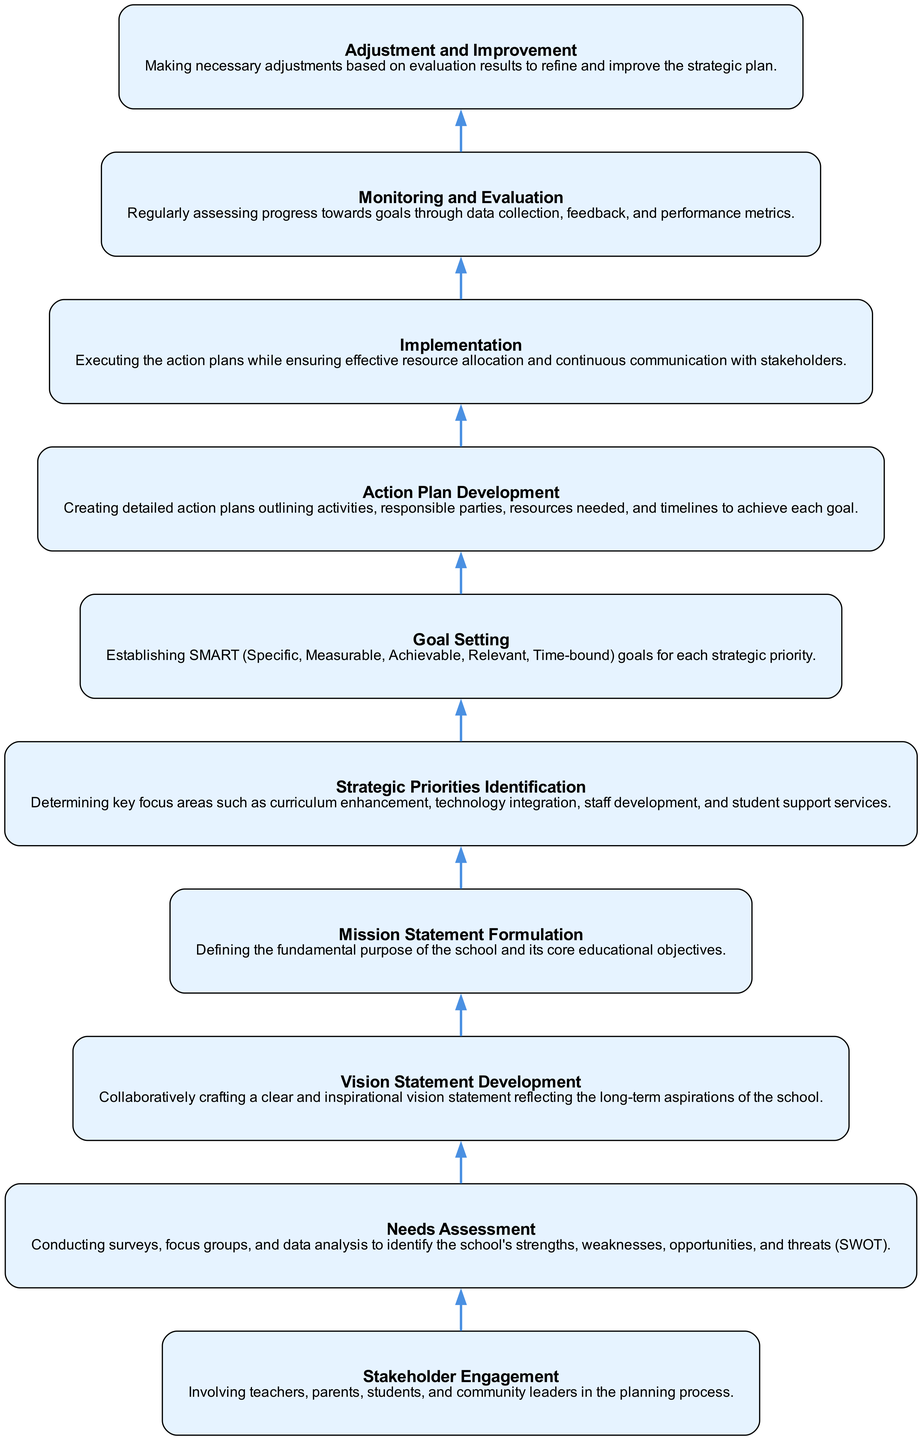What is the topmost node in the diagram? The topmost node is "Adjustment and Improvement." Since the diagram flows from bottom to top, allowing us to identify that "Adjustment and Improvement" is the final stage of the strategic planning process.
Answer: Adjustment and Improvement How many nodes are present in the diagram? There are a total of ten nodes representing various stages in the school strategic plan's development process.
Answer: Ten Which node comes directly after "Needs Assessment"? "Vision Statement Development" comes directly after "Needs Assessment." By following the flow chart from the bottom up, we can see the direct connection between these two nodes.
Answer: Vision Statement Development What is the immediate predecessor of "Goal Setting"? The immediate predecessor of "Goal Setting" is "Strategic Priorities Identification." By tracing the flow upwards from the "Goal Setting" node, it leads us directly to the preceding step in the planning process.
Answer: Strategic Priorities Identification Which node is responsible for creating action plans? "Action Plan Development" is responsible for creating action plans, as indicated by its position in the diagram and the description associated with it.
Answer: Action Plan Development What process follows "Implementation"? "Monitoring and Evaluation" follows "Implementation" in the diagram, which highlights the next critical step after executing the action plans.
Answer: Monitoring and Evaluation What is the primary focus of "Needs Assessment"? The primary focus of "Needs Assessment" is conducting surveys and data analysis to identify the school's strengths, weaknesses, opportunities, and threats. This focus is explicitly mentioned in its description.
Answer: Identifying the school's strengths, weaknesses, opportunities, and threats Which two nodes are directly connected by edges in the top half of the diagram? "Mission Statement Formulation" and "Strategic Priorities Identification" are directly connected by an edge, indicating that the output of one informs the next step in the strategic planning process.
Answer: Mission Statement Formulation and Strategic Priorities Identification What is the main goal of the "Vision Statement Development" node? The main goal is to collaboratively craft a clear and inspirational vision statement that reflects the long-term aspirations of the school. This objective is clearly stated in its description.
Answer: Crafting a clear and inspirational vision statement Which node emphasizes communication with stakeholders? The "Implementation" node emphasizes communication with stakeholders as part of executing the action plans. This aspect is highlighted in its description of the necessary activities during this phase.
Answer: Implementation 